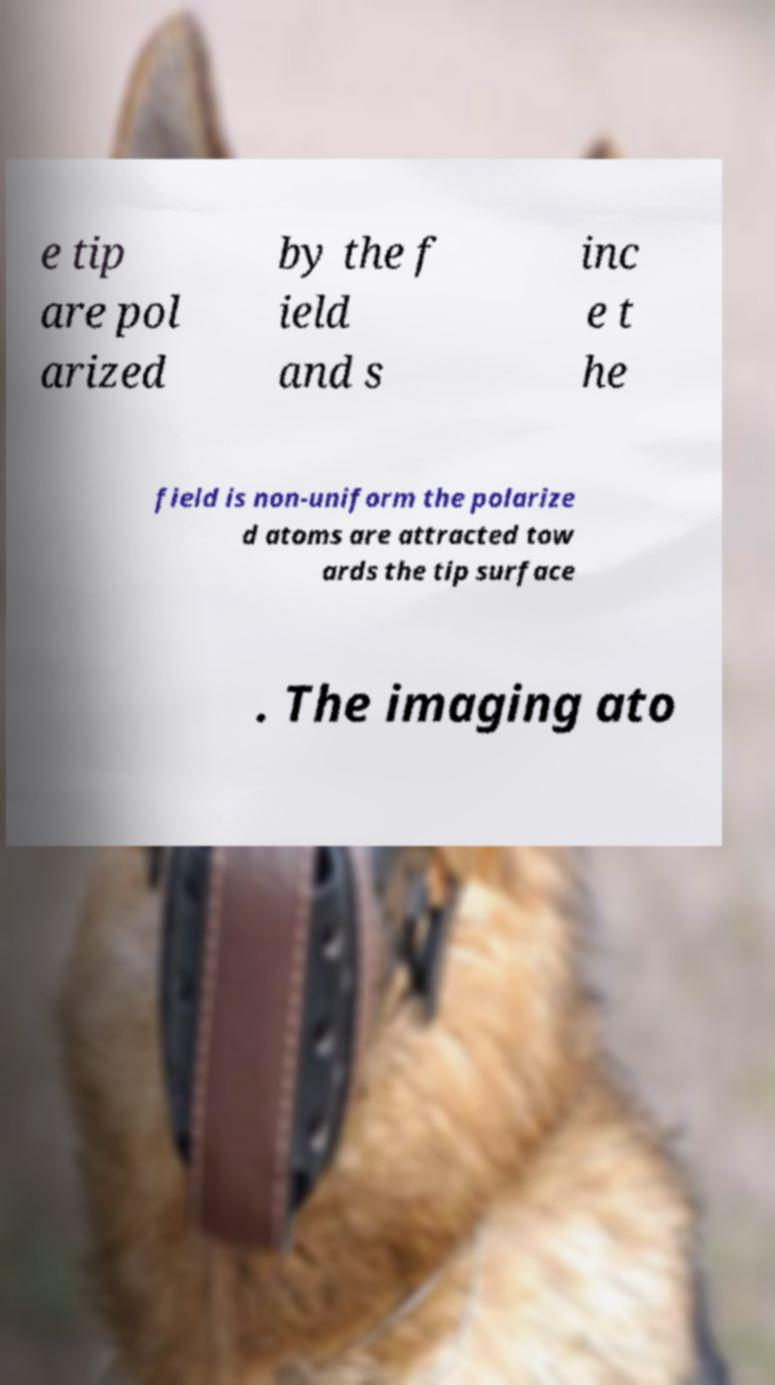There's text embedded in this image that I need extracted. Can you transcribe it verbatim? e tip are pol arized by the f ield and s inc e t he field is non-uniform the polarize d atoms are attracted tow ards the tip surface . The imaging ato 